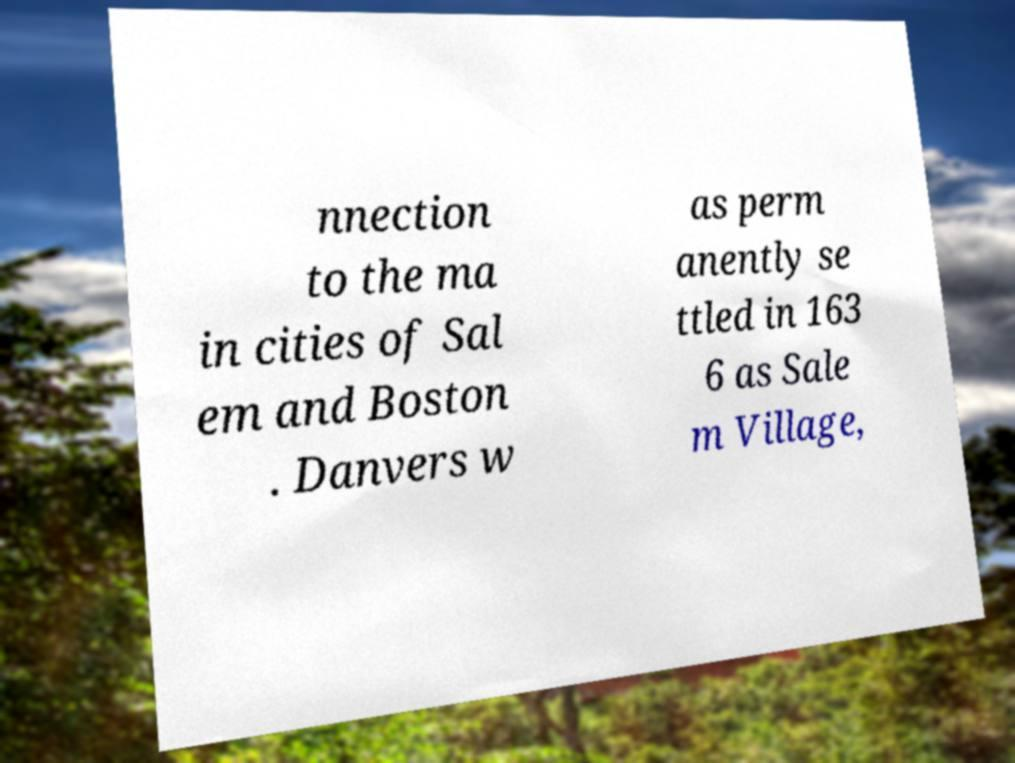Can you read and provide the text displayed in the image?This photo seems to have some interesting text. Can you extract and type it out for me? nnection to the ma in cities of Sal em and Boston . Danvers w as perm anently se ttled in 163 6 as Sale m Village, 